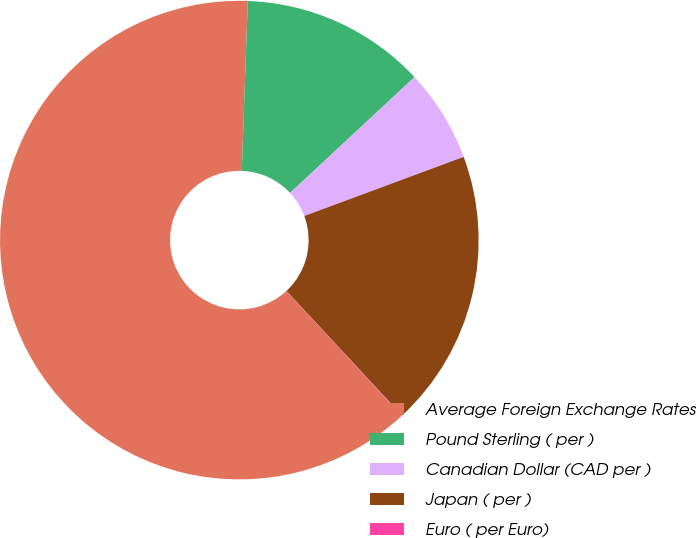<chart> <loc_0><loc_0><loc_500><loc_500><pie_chart><fcel>Average Foreign Exchange Rates<fcel>Pound Sterling ( per )<fcel>Canadian Dollar (CAD per )<fcel>Japan ( per )<fcel>Euro ( per Euro)<nl><fcel>62.43%<fcel>12.51%<fcel>6.27%<fcel>18.75%<fcel>0.03%<nl></chart> 